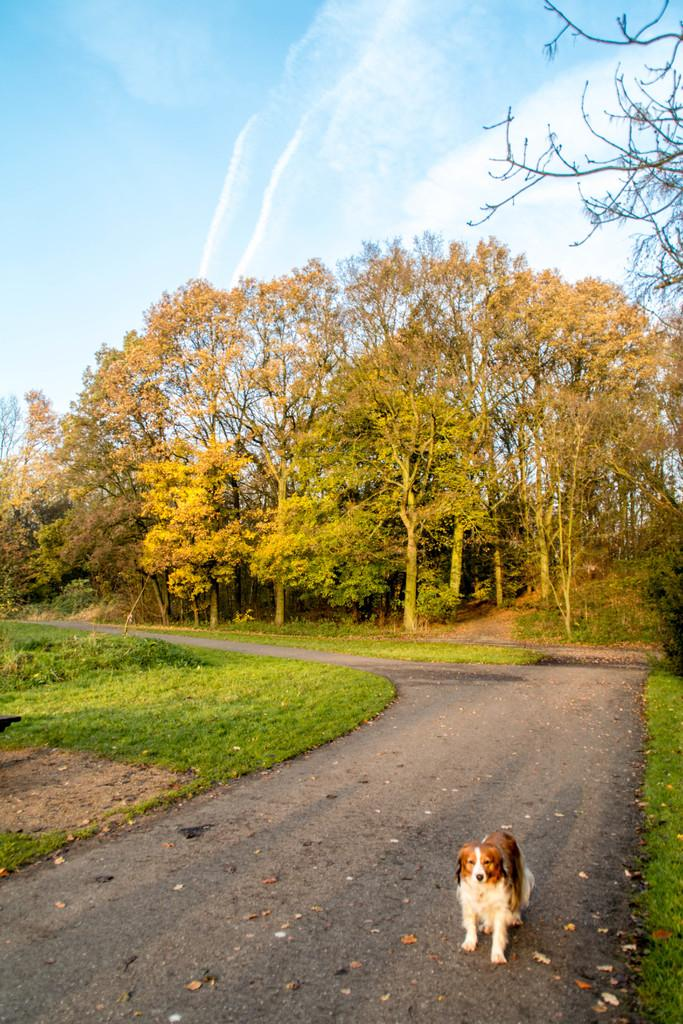What is located at the bottom of the image? There is a dog, a road, and grass at the bottom of the image. What can be seen in the middle of the image? There are trees, plants, grass, and the sky visible in the middle of the image. What is present in the sky? There are clouds in the sky. In which direction does the dog face in the image? The provided facts do not mention the direction the dog is facing, so it cannot be determined from the image. What type of division is present between the grass and the trees in the middle of the image? There is no mention of a division between the grass and the trees in the image. 